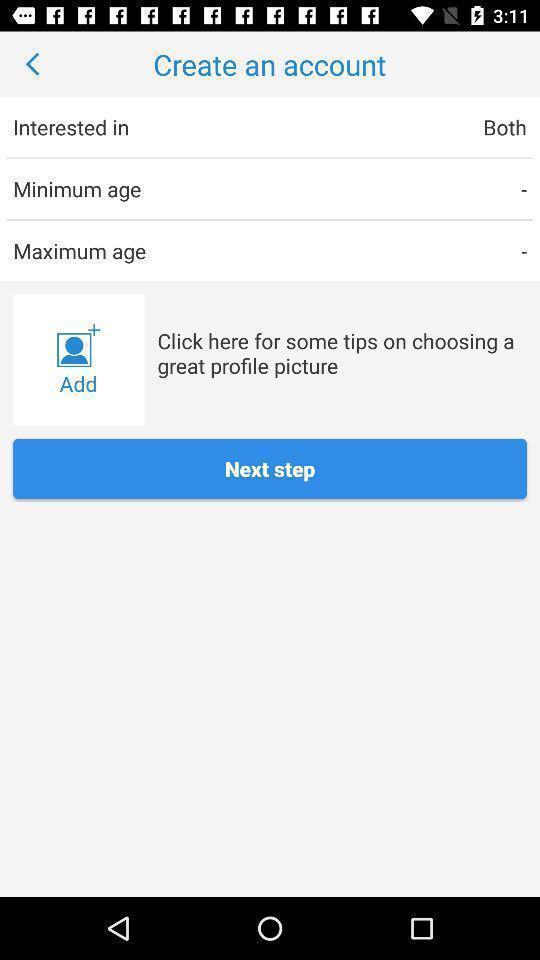What can you discern from this picture? Page shows different options in create account. 